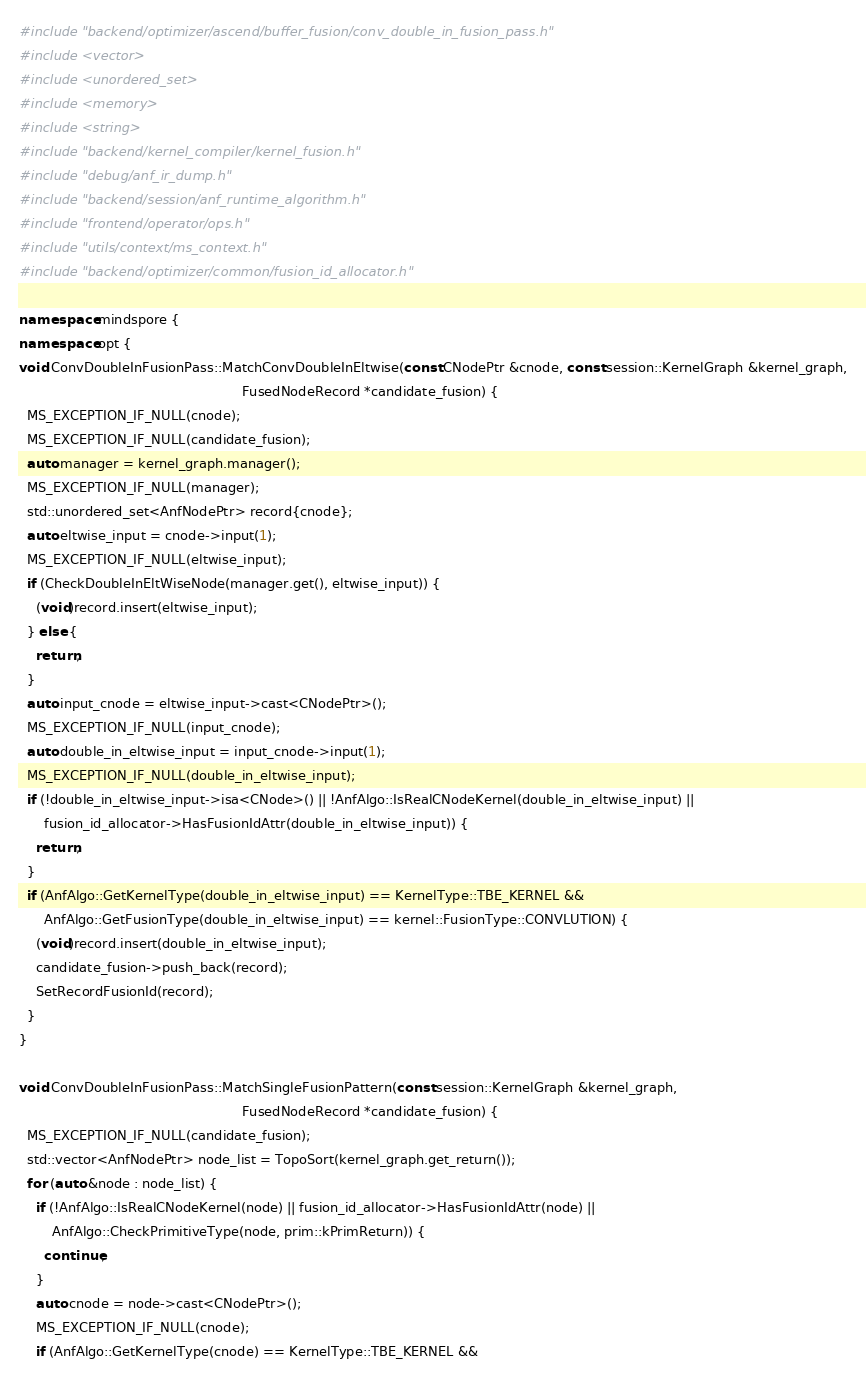Convert code to text. <code><loc_0><loc_0><loc_500><loc_500><_C++_>#include "backend/optimizer/ascend/buffer_fusion/conv_double_in_fusion_pass.h"
#include <vector>
#include <unordered_set>
#include <memory>
#include <string>
#include "backend/kernel_compiler/kernel_fusion.h"
#include "debug/anf_ir_dump.h"
#include "backend/session/anf_runtime_algorithm.h"
#include "frontend/operator/ops.h"
#include "utils/context/ms_context.h"
#include "backend/optimizer/common/fusion_id_allocator.h"

namespace mindspore {
namespace opt {
void ConvDoubleInFusionPass::MatchConvDoubleInEltwise(const CNodePtr &cnode, const session::KernelGraph &kernel_graph,
                                                      FusedNodeRecord *candidate_fusion) {
  MS_EXCEPTION_IF_NULL(cnode);
  MS_EXCEPTION_IF_NULL(candidate_fusion);
  auto manager = kernel_graph.manager();
  MS_EXCEPTION_IF_NULL(manager);
  std::unordered_set<AnfNodePtr> record{cnode};
  auto eltwise_input = cnode->input(1);
  MS_EXCEPTION_IF_NULL(eltwise_input);
  if (CheckDoubleInEltWiseNode(manager.get(), eltwise_input)) {
    (void)record.insert(eltwise_input);
  } else {
    return;
  }
  auto input_cnode = eltwise_input->cast<CNodePtr>();
  MS_EXCEPTION_IF_NULL(input_cnode);
  auto double_in_eltwise_input = input_cnode->input(1);
  MS_EXCEPTION_IF_NULL(double_in_eltwise_input);
  if (!double_in_eltwise_input->isa<CNode>() || !AnfAlgo::IsRealCNodeKernel(double_in_eltwise_input) ||
      fusion_id_allocator->HasFusionIdAttr(double_in_eltwise_input)) {
    return;
  }
  if (AnfAlgo::GetKernelType(double_in_eltwise_input) == KernelType::TBE_KERNEL &&
      AnfAlgo::GetFusionType(double_in_eltwise_input) == kernel::FusionType::CONVLUTION) {
    (void)record.insert(double_in_eltwise_input);
    candidate_fusion->push_back(record);
    SetRecordFusionId(record);
  }
}

void ConvDoubleInFusionPass::MatchSingleFusionPattern(const session::KernelGraph &kernel_graph,
                                                      FusedNodeRecord *candidate_fusion) {
  MS_EXCEPTION_IF_NULL(candidate_fusion);
  std::vector<AnfNodePtr> node_list = TopoSort(kernel_graph.get_return());
  for (auto &node : node_list) {
    if (!AnfAlgo::IsRealCNodeKernel(node) || fusion_id_allocator->HasFusionIdAttr(node) ||
        AnfAlgo::CheckPrimitiveType(node, prim::kPrimReturn)) {
      continue;
    }
    auto cnode = node->cast<CNodePtr>();
    MS_EXCEPTION_IF_NULL(cnode);
    if (AnfAlgo::GetKernelType(cnode) == KernelType::TBE_KERNEL &&</code> 